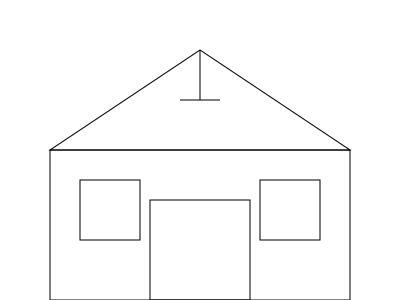Based on the front elevation drawing of Mr. Norman Gould Allen's house, which architectural style does it most closely resemble? To determine the architectural style of Mr. Allen's house, let's analyze the key features visible in the front elevation drawing:

1. Symmetrical design: The house has a balanced appearance with evenly placed windows on either side of the central door.

2. Steeply pitched roof: The roof forms a distinct triangular shape, indicative of a high pitch.

3. Central chimney: There's a chimney visible at the center of the roof peak.

4. Rectangular shape: The main structure of the house is a simple rectangle.

5. Centrally located door: The entrance is positioned in the middle of the façade.

6. Multi-pane windows: The windows appear to be divided into multiple panes.

These features are characteristic of the Cape Cod style, which originated in New England in the 17th century and experienced a revival in the 20th century. Cape Cod houses are known for their simplicity, functionality, and ability to withstand harsh weather conditions.

The steep roof is designed to shed snow and rain, while the central chimney provides efficient heating. The symmetrical design and centrally located door are also hallmarks of this style. The multi-pane windows are typical of traditional Cape Cod houses, allowing for ample natural light while maintaining structural integrity against coastal winds.

While there are variations within the Cape Cod style, this front elevation drawing strongly suggests that Mr. Allen's house is a classic example of Cape Cod architecture.
Answer: Cape Cod 